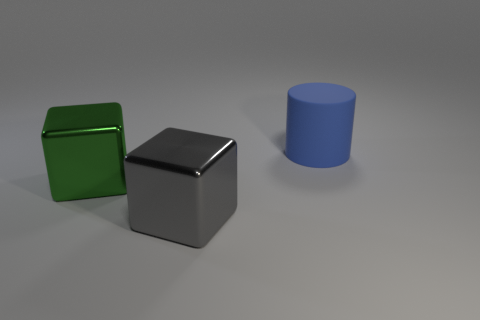What materials do the objects in the image appear to be made from? The objects in the image seem to be rendered with different materials. The green and silver cubes look as if they have a smooth metallic surface, which could be indicative of a metal or a reflective plastic. The blue cylinder has a more matte appearance, suggesting a possible ceramic or painted wood construction. 